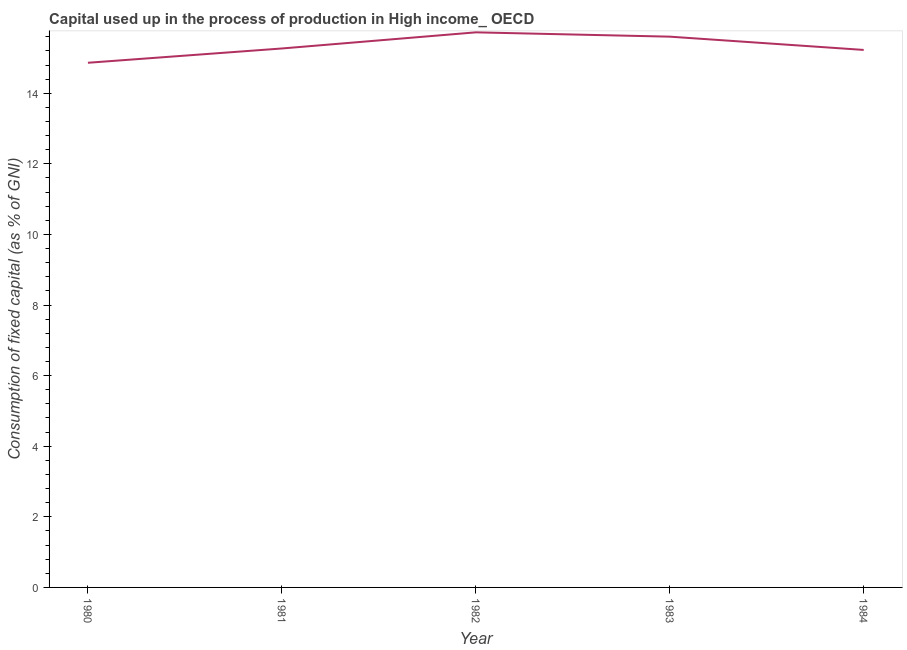What is the consumption of fixed capital in 1982?
Your response must be concise. 15.73. Across all years, what is the maximum consumption of fixed capital?
Provide a succinct answer. 15.73. Across all years, what is the minimum consumption of fixed capital?
Your answer should be compact. 14.86. In which year was the consumption of fixed capital maximum?
Keep it short and to the point. 1982. What is the sum of the consumption of fixed capital?
Keep it short and to the point. 76.69. What is the difference between the consumption of fixed capital in 1981 and 1982?
Your answer should be compact. -0.46. What is the average consumption of fixed capital per year?
Offer a terse response. 15.34. What is the median consumption of fixed capital?
Your answer should be compact. 15.27. In how many years, is the consumption of fixed capital greater than 2.8 %?
Offer a terse response. 5. Do a majority of the years between 1983 and 1984 (inclusive) have consumption of fixed capital greater than 13.2 %?
Provide a succinct answer. Yes. What is the ratio of the consumption of fixed capital in 1981 to that in 1982?
Your response must be concise. 0.97. What is the difference between the highest and the second highest consumption of fixed capital?
Ensure brevity in your answer.  0.12. Is the sum of the consumption of fixed capital in 1980 and 1981 greater than the maximum consumption of fixed capital across all years?
Offer a very short reply. Yes. What is the difference between the highest and the lowest consumption of fixed capital?
Your answer should be compact. 0.86. In how many years, is the consumption of fixed capital greater than the average consumption of fixed capital taken over all years?
Your response must be concise. 2. Does the consumption of fixed capital monotonically increase over the years?
Keep it short and to the point. No. How many lines are there?
Offer a terse response. 1. Are the values on the major ticks of Y-axis written in scientific E-notation?
Keep it short and to the point. No. What is the title of the graph?
Ensure brevity in your answer.  Capital used up in the process of production in High income_ OECD. What is the label or title of the X-axis?
Make the answer very short. Year. What is the label or title of the Y-axis?
Your answer should be very brief. Consumption of fixed capital (as % of GNI). What is the Consumption of fixed capital (as % of GNI) in 1980?
Your answer should be compact. 14.86. What is the Consumption of fixed capital (as % of GNI) in 1981?
Make the answer very short. 15.27. What is the Consumption of fixed capital (as % of GNI) in 1982?
Offer a very short reply. 15.73. What is the Consumption of fixed capital (as % of GNI) in 1983?
Offer a terse response. 15.6. What is the Consumption of fixed capital (as % of GNI) of 1984?
Ensure brevity in your answer.  15.23. What is the difference between the Consumption of fixed capital (as % of GNI) in 1980 and 1981?
Make the answer very short. -0.4. What is the difference between the Consumption of fixed capital (as % of GNI) in 1980 and 1982?
Your answer should be very brief. -0.86. What is the difference between the Consumption of fixed capital (as % of GNI) in 1980 and 1983?
Make the answer very short. -0.74. What is the difference between the Consumption of fixed capital (as % of GNI) in 1980 and 1984?
Offer a terse response. -0.36. What is the difference between the Consumption of fixed capital (as % of GNI) in 1981 and 1982?
Your answer should be very brief. -0.46. What is the difference between the Consumption of fixed capital (as % of GNI) in 1981 and 1983?
Give a very brief answer. -0.33. What is the difference between the Consumption of fixed capital (as % of GNI) in 1981 and 1984?
Keep it short and to the point. 0.04. What is the difference between the Consumption of fixed capital (as % of GNI) in 1982 and 1983?
Your answer should be very brief. 0.12. What is the difference between the Consumption of fixed capital (as % of GNI) in 1982 and 1984?
Ensure brevity in your answer.  0.5. What is the difference between the Consumption of fixed capital (as % of GNI) in 1983 and 1984?
Offer a terse response. 0.38. What is the ratio of the Consumption of fixed capital (as % of GNI) in 1980 to that in 1982?
Give a very brief answer. 0.94. What is the ratio of the Consumption of fixed capital (as % of GNI) in 1980 to that in 1983?
Keep it short and to the point. 0.95. What is the ratio of the Consumption of fixed capital (as % of GNI) in 1981 to that in 1983?
Offer a very short reply. 0.98. What is the ratio of the Consumption of fixed capital (as % of GNI) in 1982 to that in 1983?
Your answer should be compact. 1.01. What is the ratio of the Consumption of fixed capital (as % of GNI) in 1982 to that in 1984?
Make the answer very short. 1.03. What is the ratio of the Consumption of fixed capital (as % of GNI) in 1983 to that in 1984?
Give a very brief answer. 1.02. 